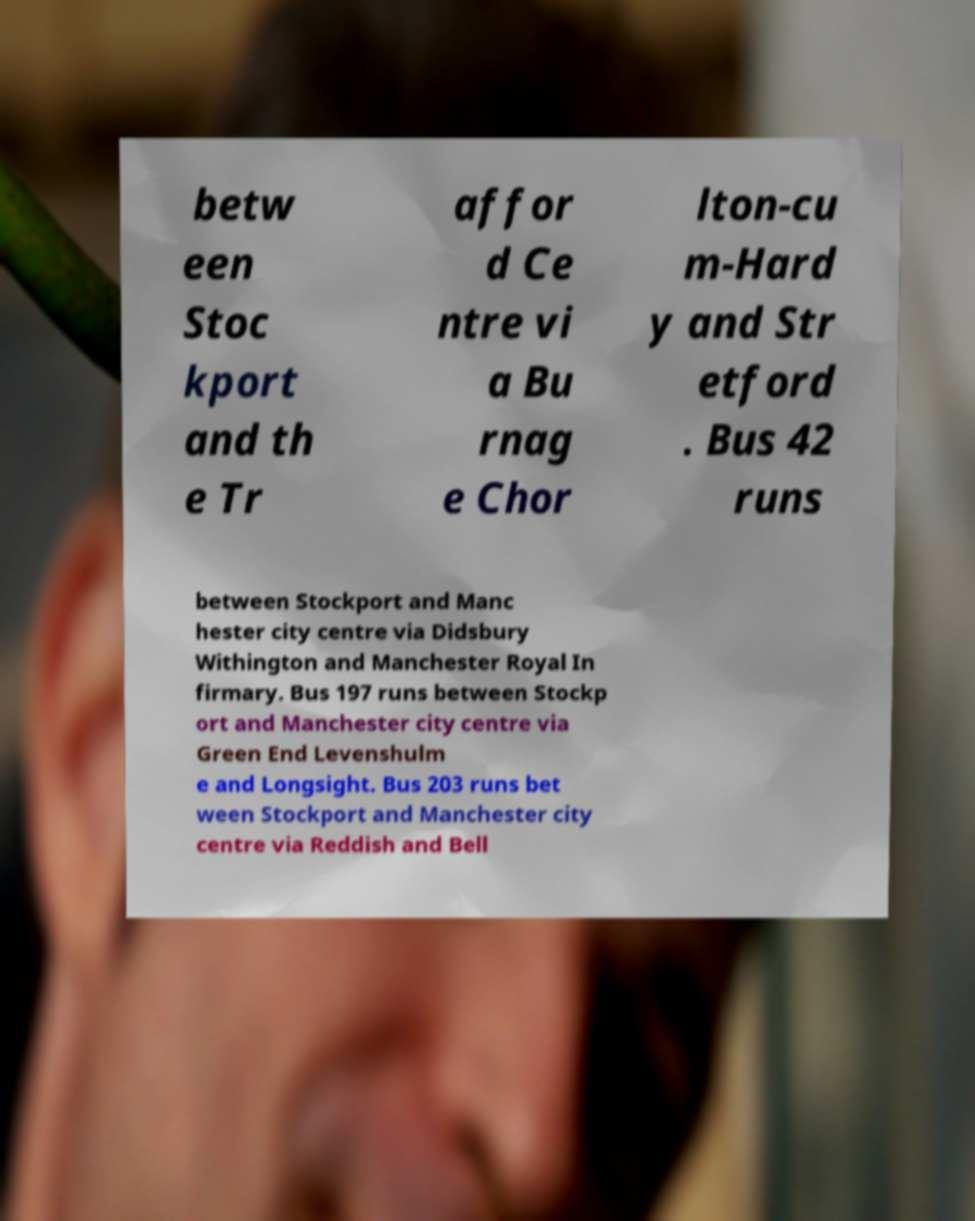Can you read and provide the text displayed in the image?This photo seems to have some interesting text. Can you extract and type it out for me? betw een Stoc kport and th e Tr affor d Ce ntre vi a Bu rnag e Chor lton-cu m-Hard y and Str etford . Bus 42 runs between Stockport and Manc hester city centre via Didsbury Withington and Manchester Royal In firmary. Bus 197 runs between Stockp ort and Manchester city centre via Green End Levenshulm e and Longsight. Bus 203 runs bet ween Stockport and Manchester city centre via Reddish and Bell 